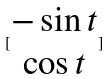Convert formula to latex. <formula><loc_0><loc_0><loc_500><loc_500>[ \begin{matrix} - \sin t \\ \cos t \end{matrix} ]</formula> 